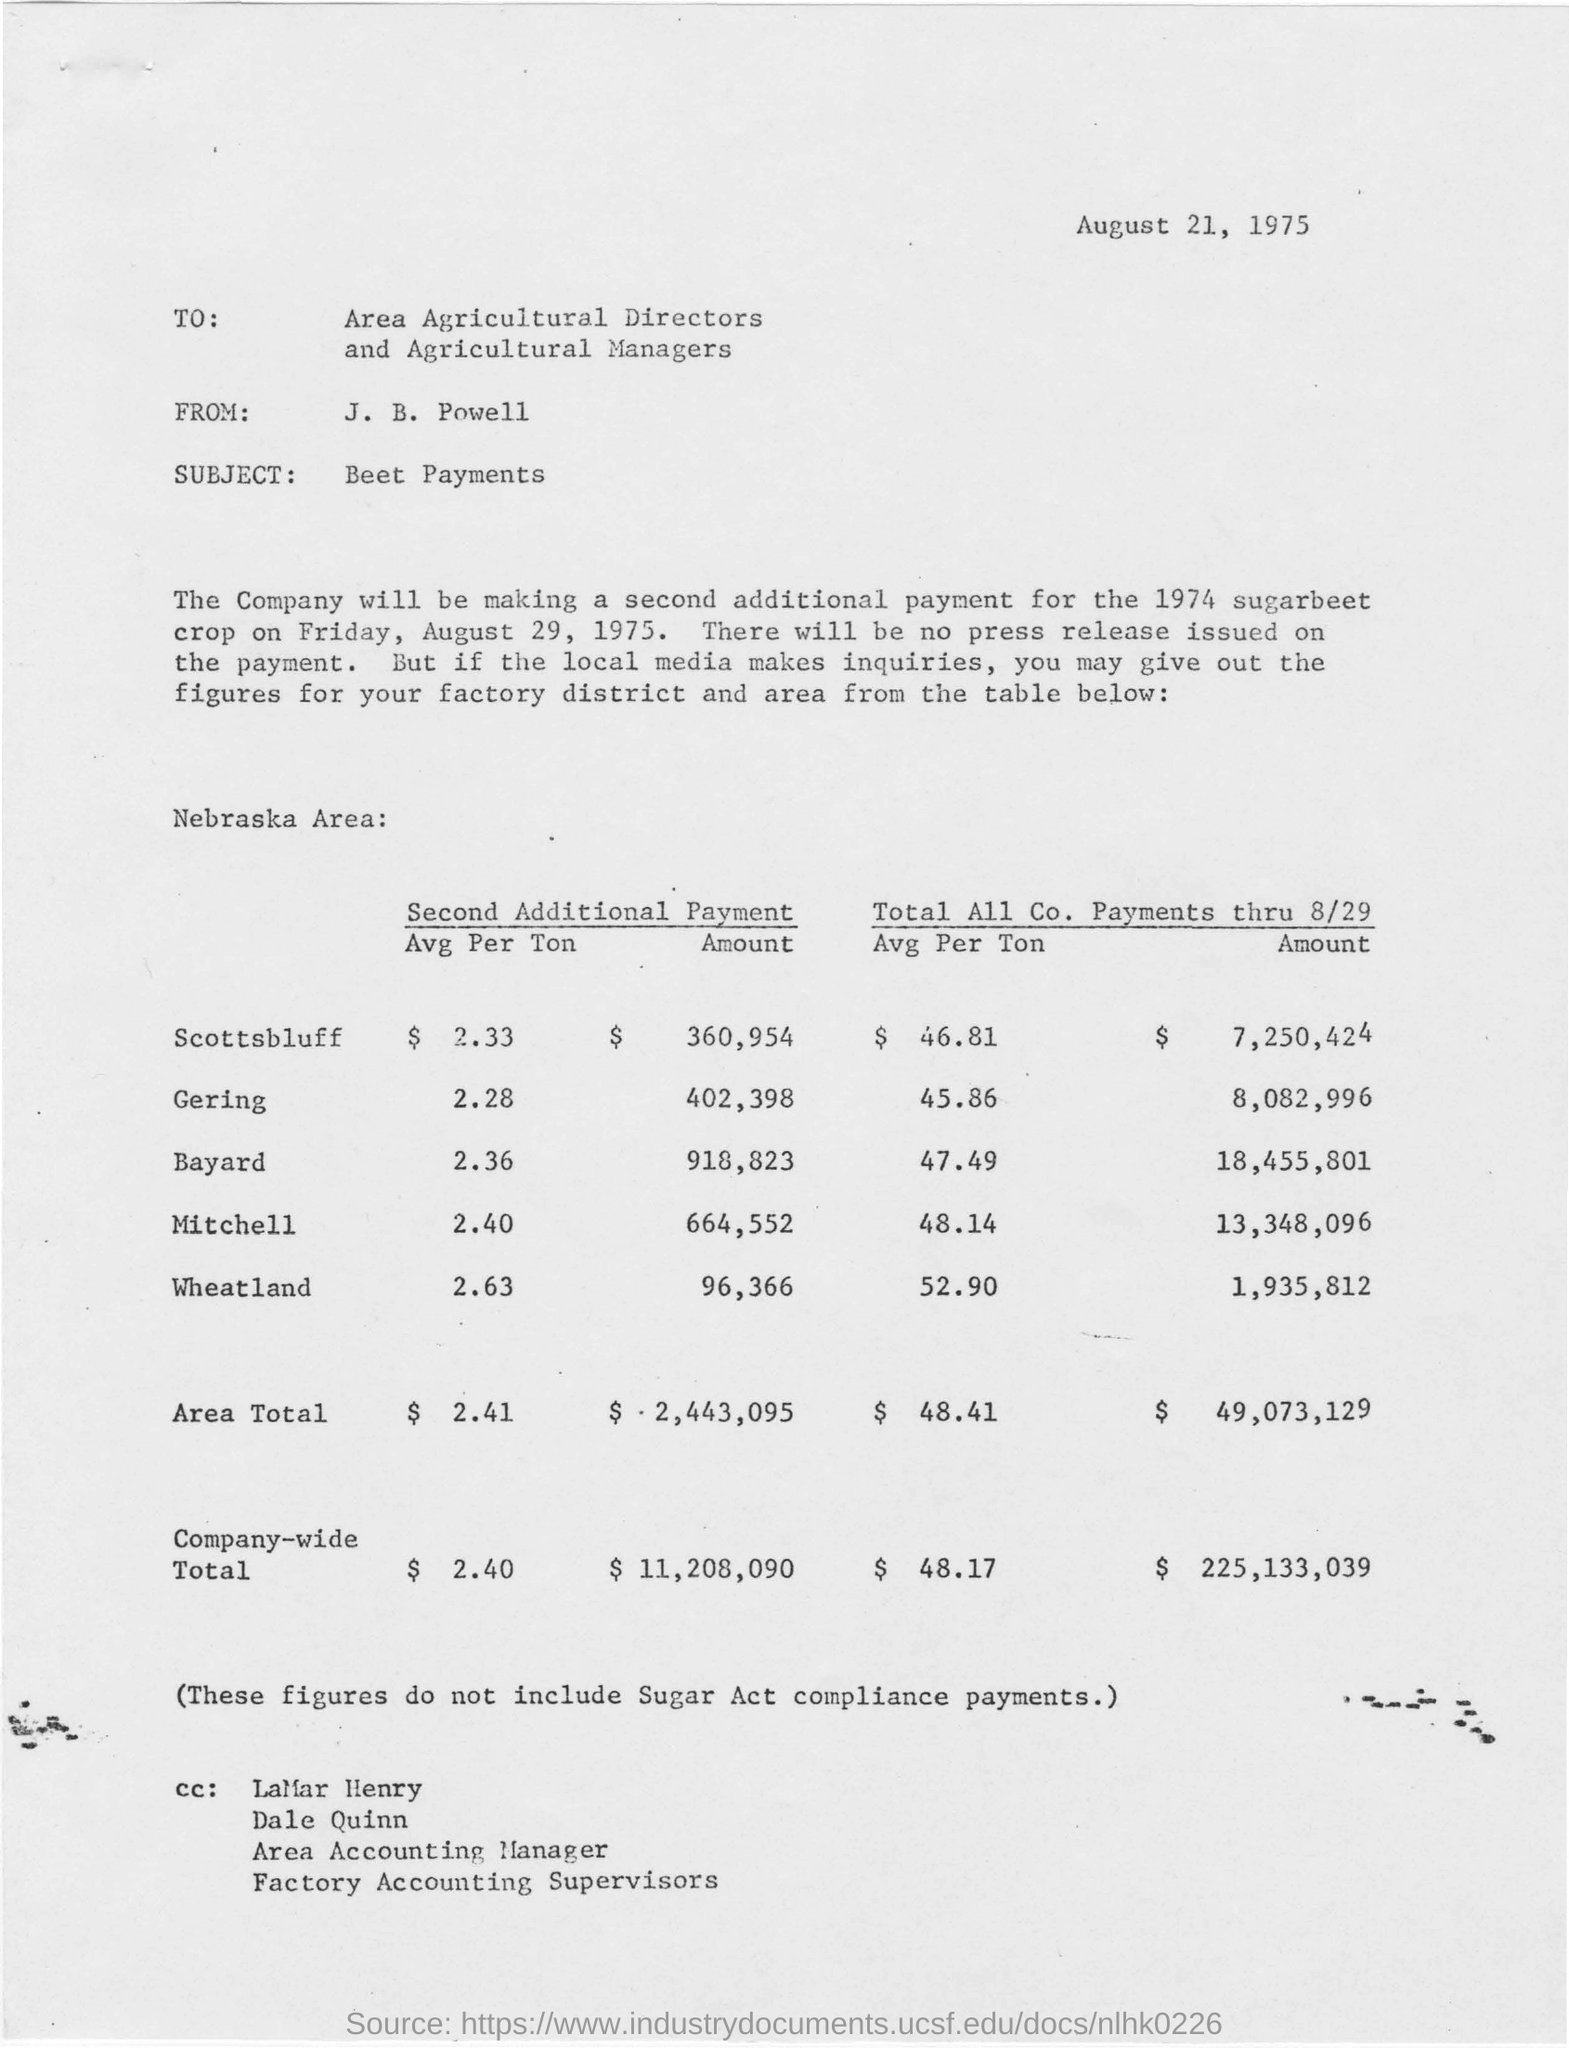Point out several critical features in this image. The subject of the letter is beet payments. The sender of the letter is J.B. Powell. The letter is intended for the recipients of the letter, which are the area agricultural directors and agricultural managers. The issued date of this letter is August 21, 1975. 